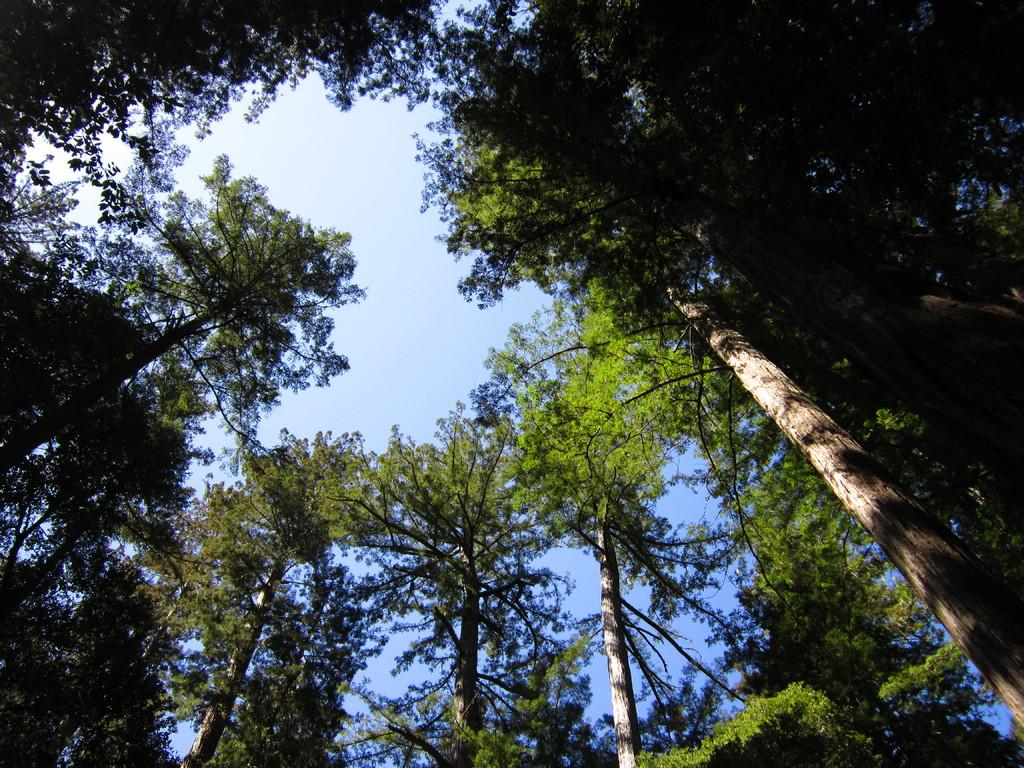What type of vegetation can be seen in the image? There are trees in the image. What is the color of the trees? The trees are green in color. What can be seen in the background of the image? The sky is visible in the background of the image. What colors are present in the sky? The sky has both white and blue colors. Where is the ornament hanging from the trees in the image? There is no ornament hanging from the trees in the image. What sound does the bell make in the image? There is no bell present in the image. 